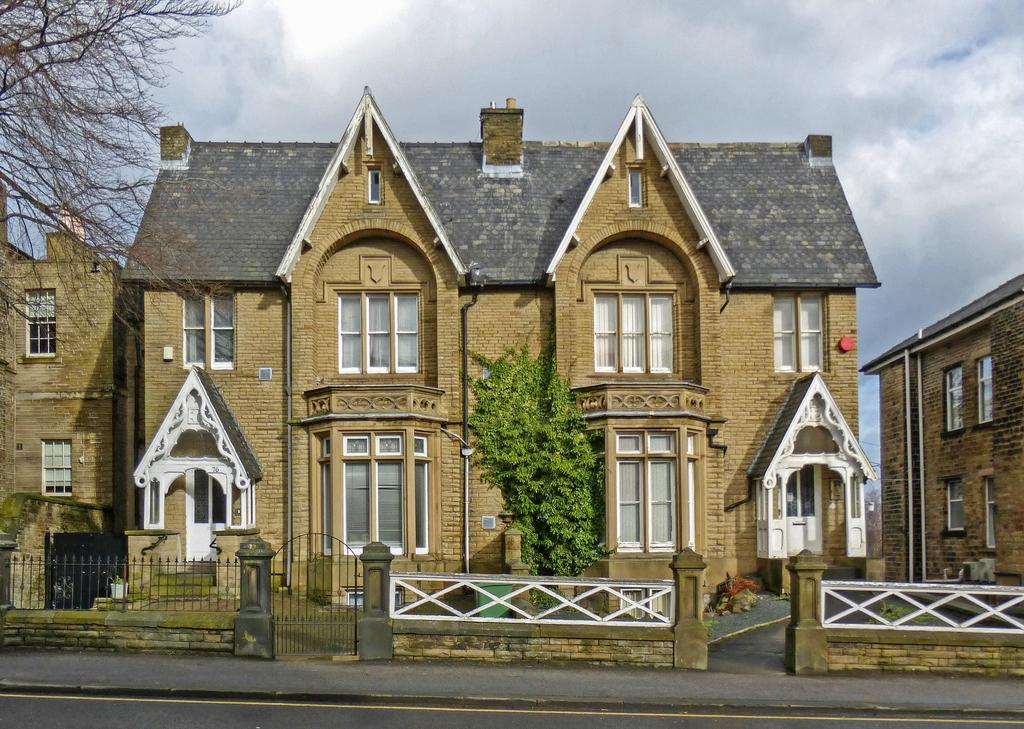What type of structures are present in the image? There are buildings in the image. What features do the buildings have? The buildings have doors and windows. What other elements can be seen in the image besides the buildings? There are trees in the image. What is visible at the top of the image? The sky is visible at the top of the image. How would you describe the sky in the image? The sky appears to be cloudy. Can you see any lace curtains in the windows of the buildings in the image? There is no information about the type of curtains or window treatments in the image, so we cannot determine if there are any lace curtains. How does the image look from the seashore? The image does not provide any information about its location or proximity to a seashore, so we cannot answer this question. 